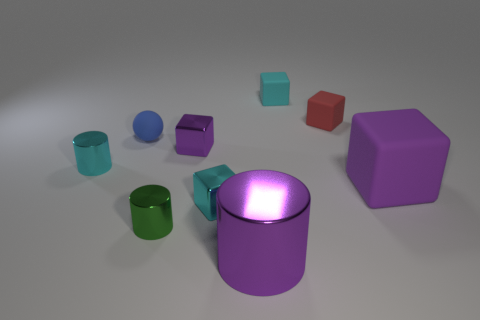What color is the metallic object that is in front of the tiny green metal cylinder that is in front of the large purple rubber cube?
Provide a short and direct response. Purple. Do the big object that is on the right side of the big metallic cylinder and the big shiny object have the same color?
Your answer should be very brief. Yes. What shape is the cyan thing to the right of the small metallic thing that is to the right of the purple metal object that is behind the tiny green shiny object?
Your answer should be compact. Cube. There is a tiny cyan thing right of the purple shiny cylinder; what number of small blocks are to the right of it?
Your answer should be very brief. 1. Is the material of the small red thing the same as the small purple object?
Your answer should be compact. No. There is a purple block that is in front of the metallic thing that is behind the small cyan cylinder; how many small things are behind it?
Provide a short and direct response. 5. What is the color of the big object that is behind the big purple cylinder?
Your answer should be compact. Purple. There is a cyan thing that is behind the tiny cylinder behind the tiny green cylinder; what is its shape?
Your answer should be very brief. Cube. Is the big matte object the same color as the big cylinder?
Offer a very short reply. Yes. How many cylinders are cyan objects or small red objects?
Offer a very short reply. 1. 